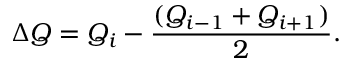Convert formula to latex. <formula><loc_0><loc_0><loc_500><loc_500>\Delta Q = Q _ { i } - \frac { ( Q _ { i - 1 } + Q _ { i + 1 } ) } { 2 } .</formula> 